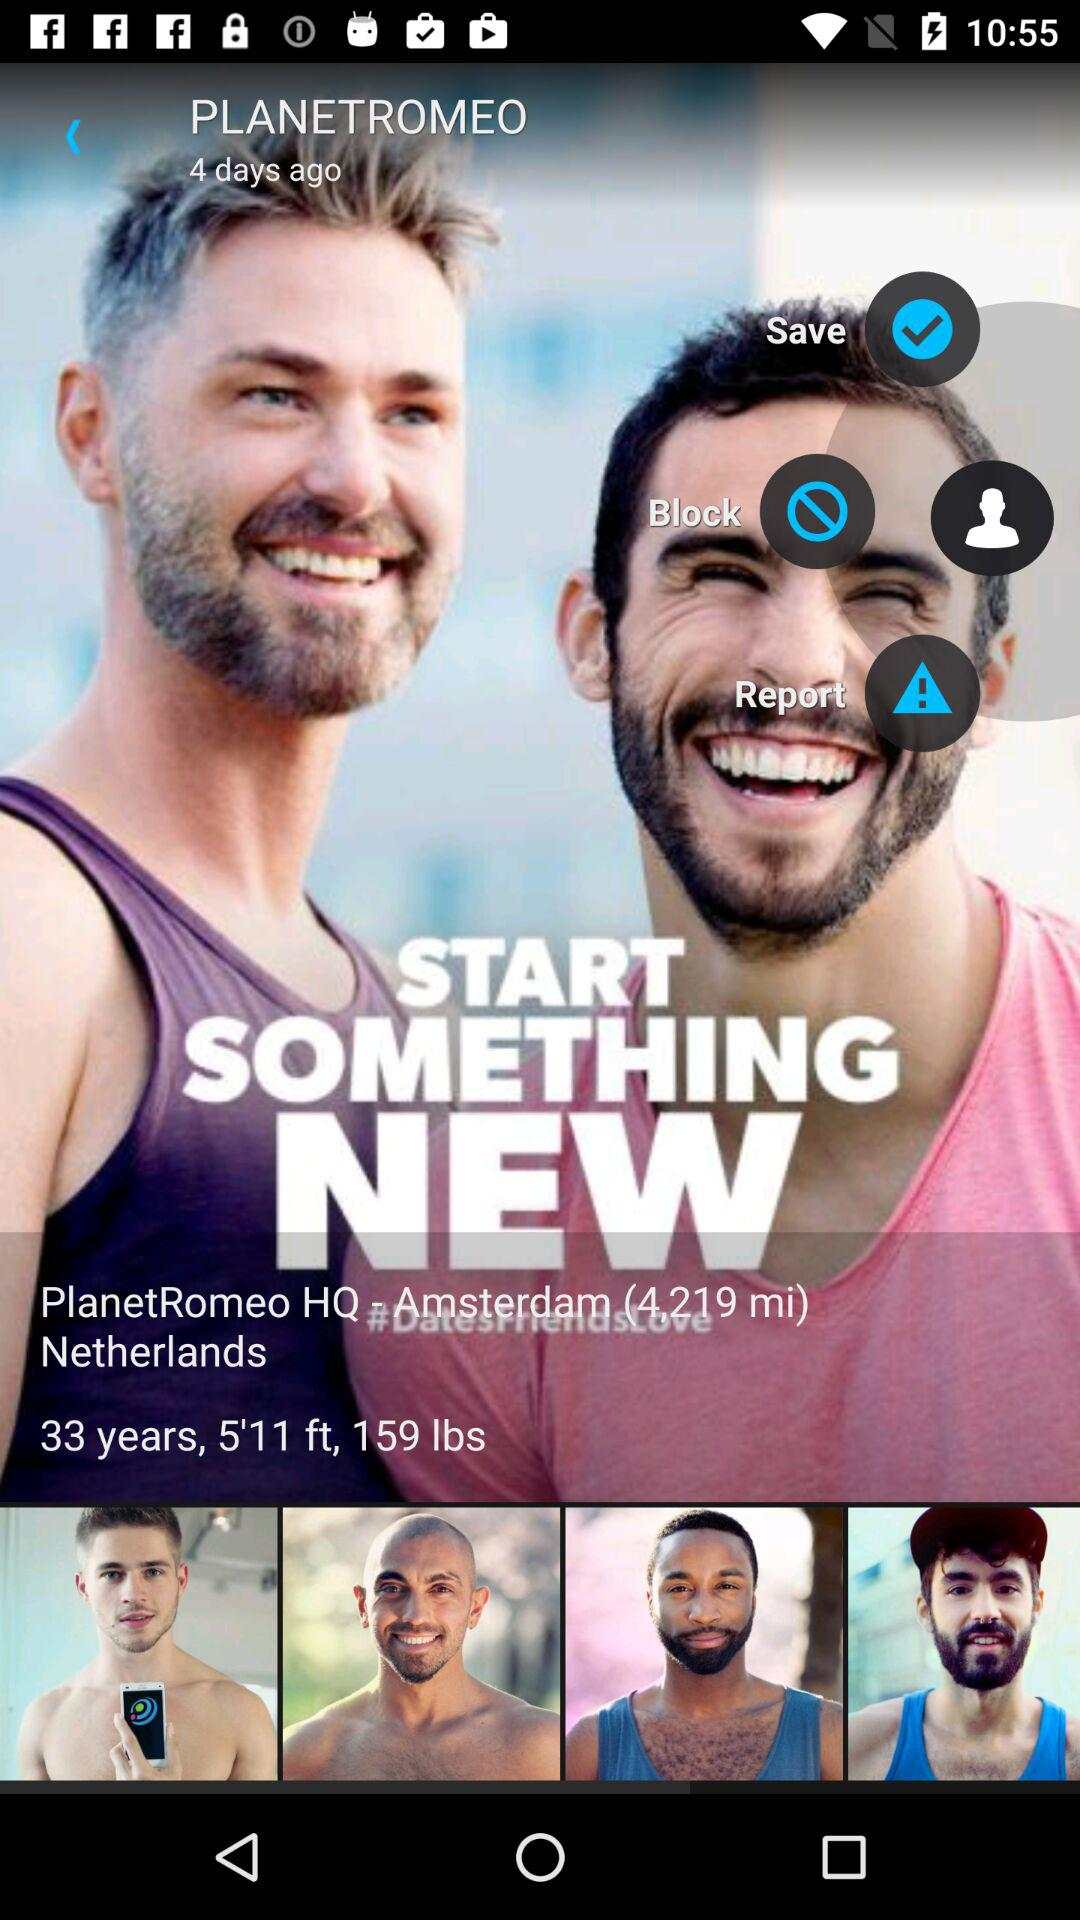What is the weight? The weight is 159 lbs. 